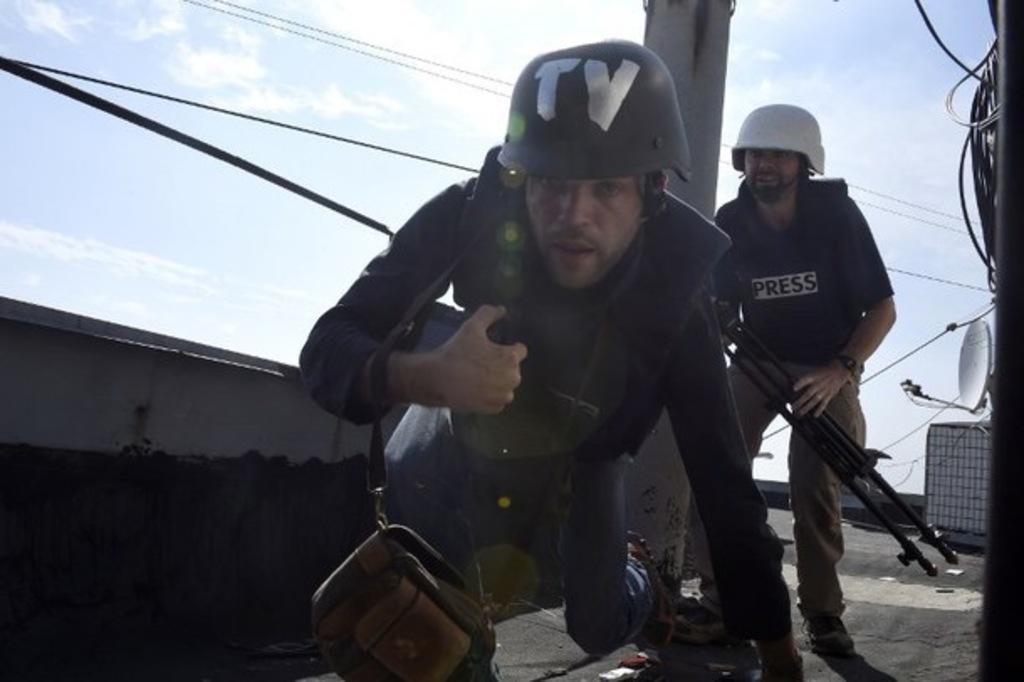How would you summarize this image in a sentence or two? In this picture we can see two men in the front, they wore helmets, a man in the front is carrying a bag, a man on the right side is holding a tripod, on the right side there is a satellite dish and wires, we can see the sky at the top of the picture. 